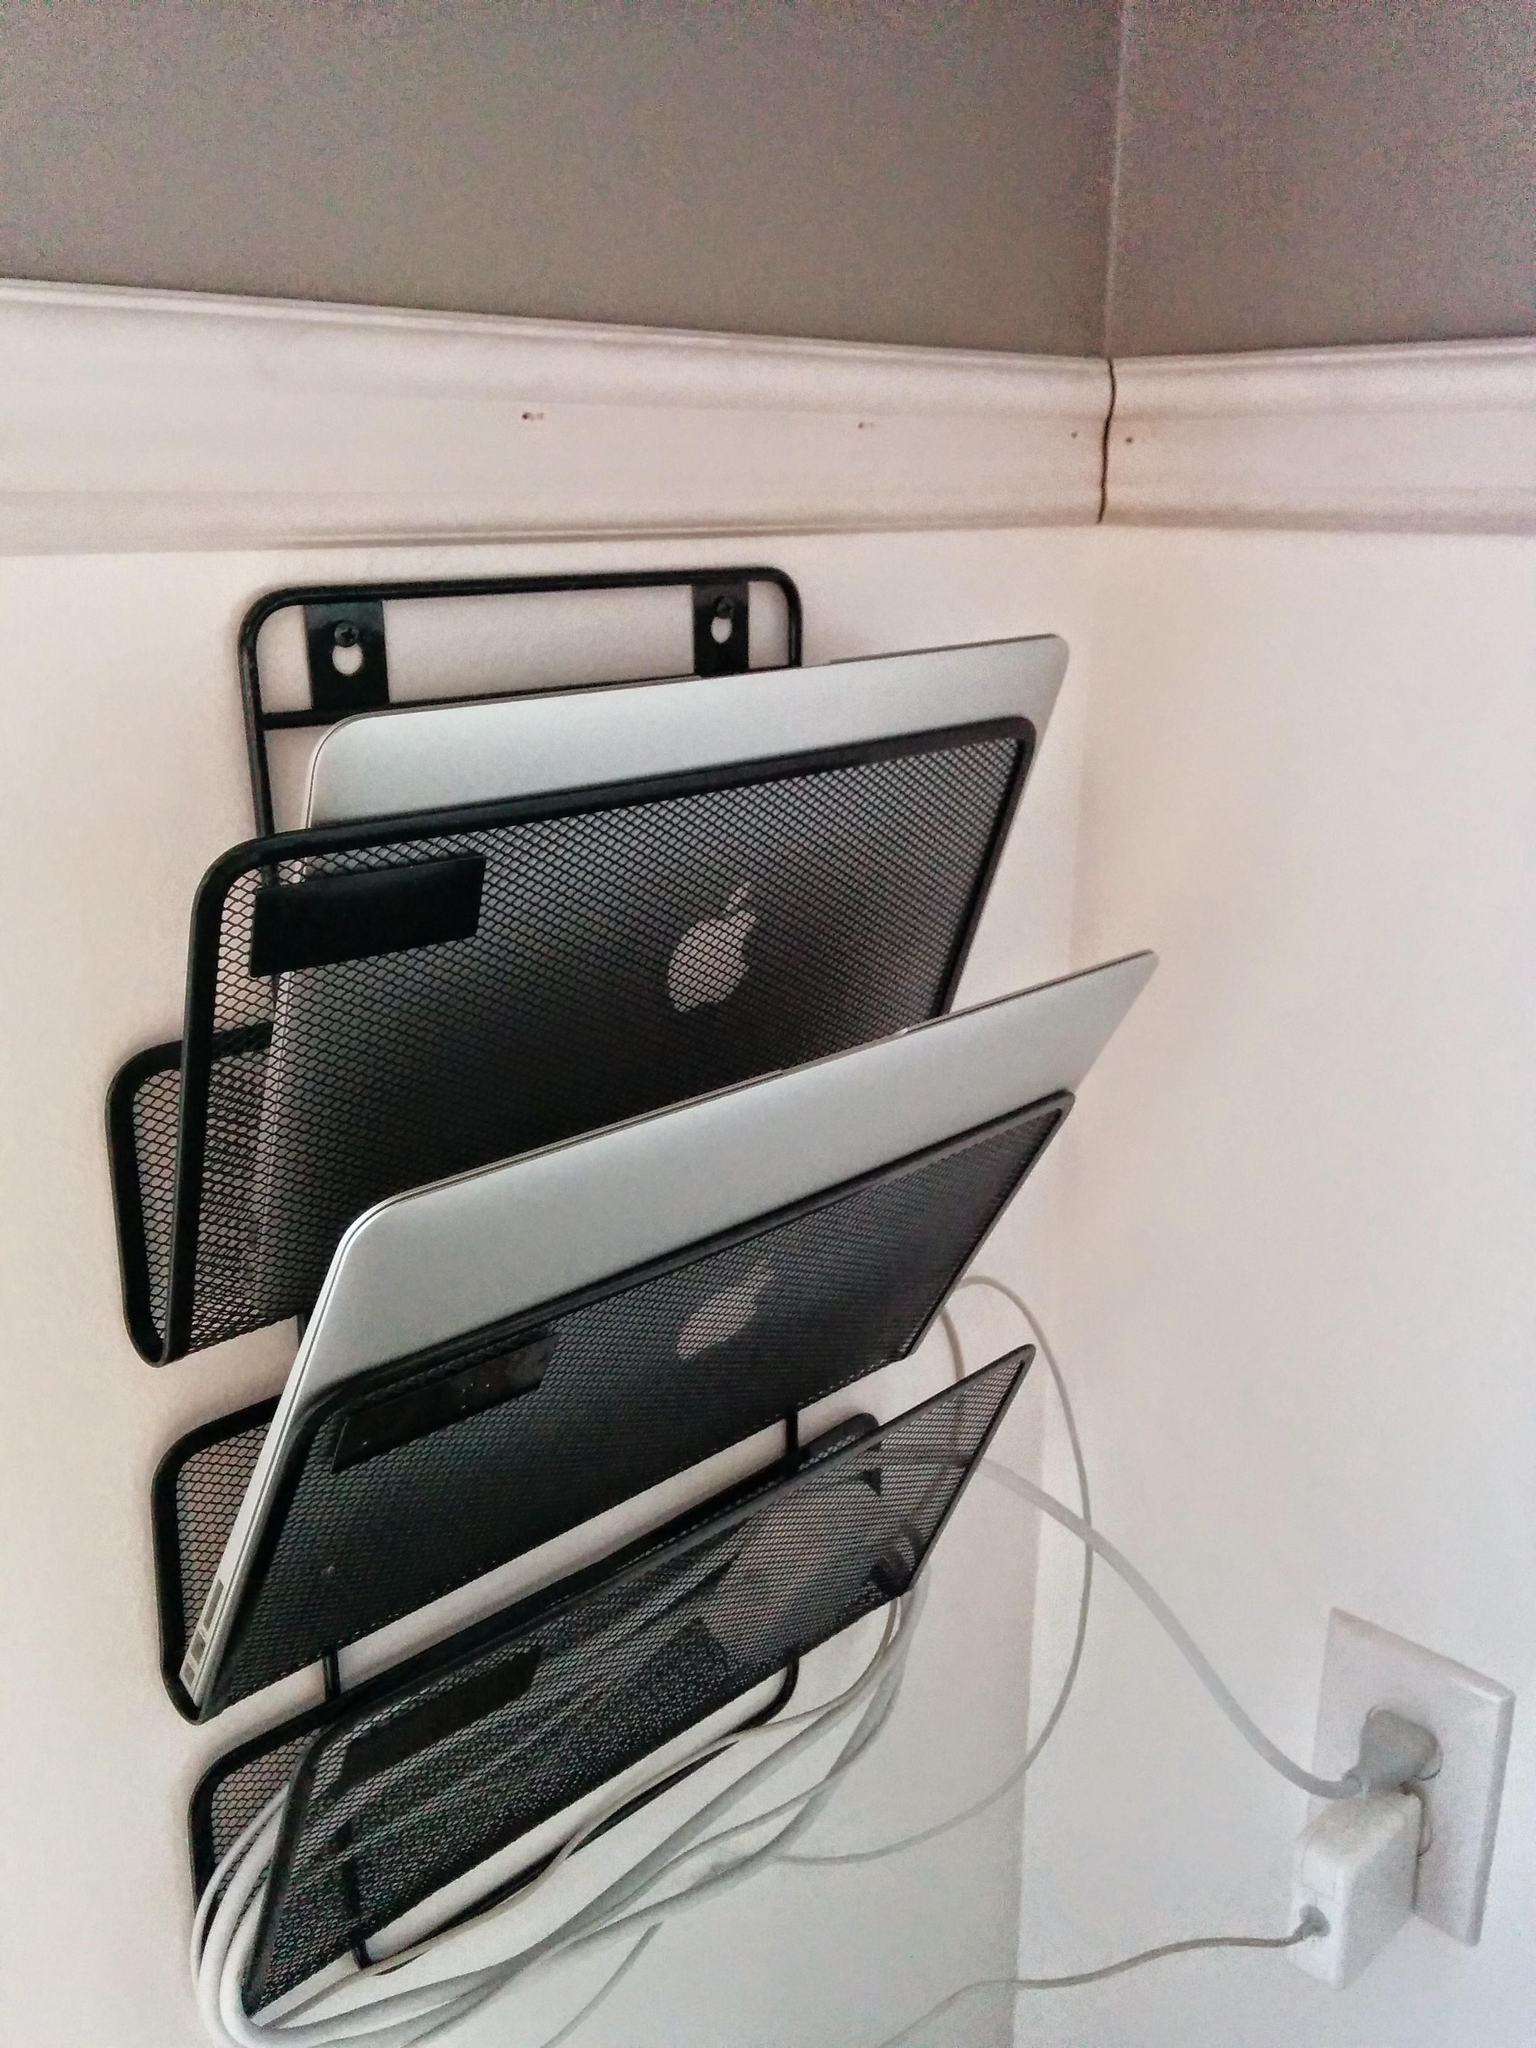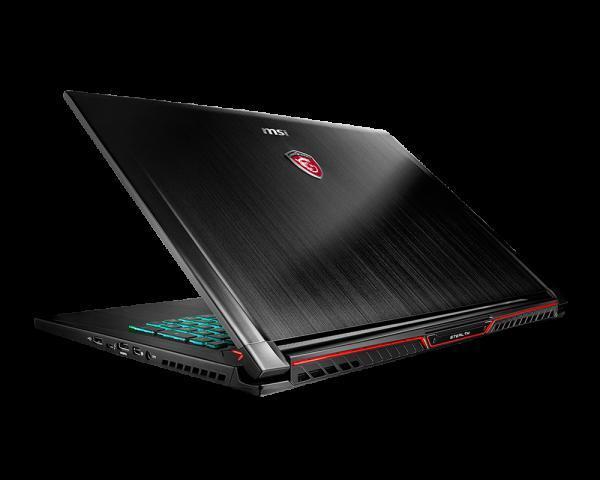The first image is the image on the left, the second image is the image on the right. For the images shown, is this caption "There is a black laptop that is opened." true? Answer yes or no. Yes. The first image is the image on the left, the second image is the image on the right. Examine the images to the left and right. Is the description "there is a pile of laptops in the image on the left, and all visible screens are dark" accurate? Answer yes or no. No. 